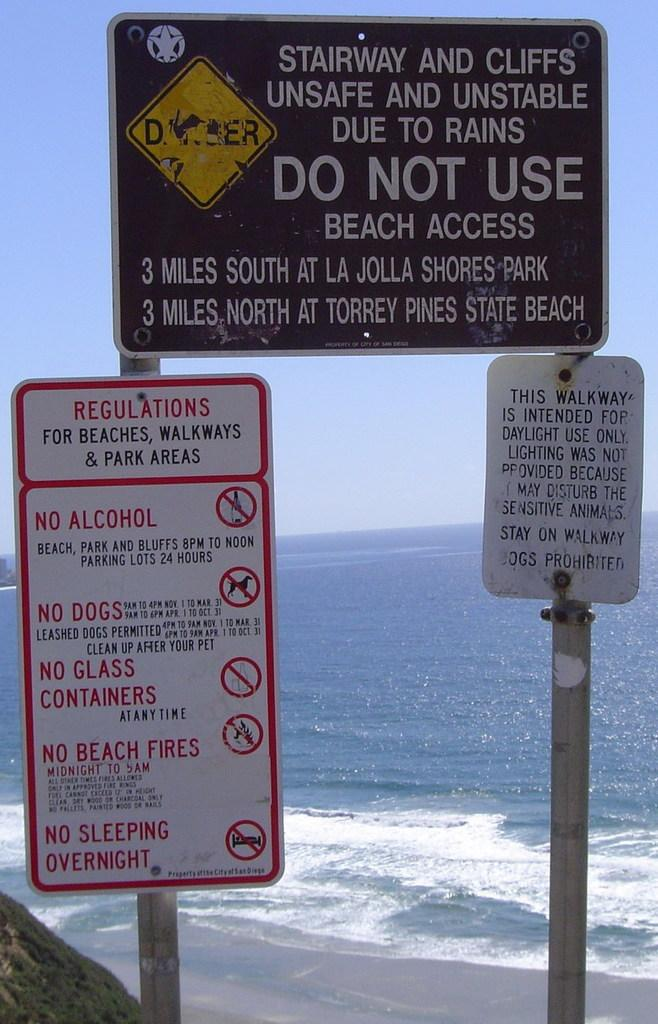<image>
Offer a succinct explanation of the picture presented. signs outside of a beach with one that says 'regulations for beaches, walkways & park areas' 